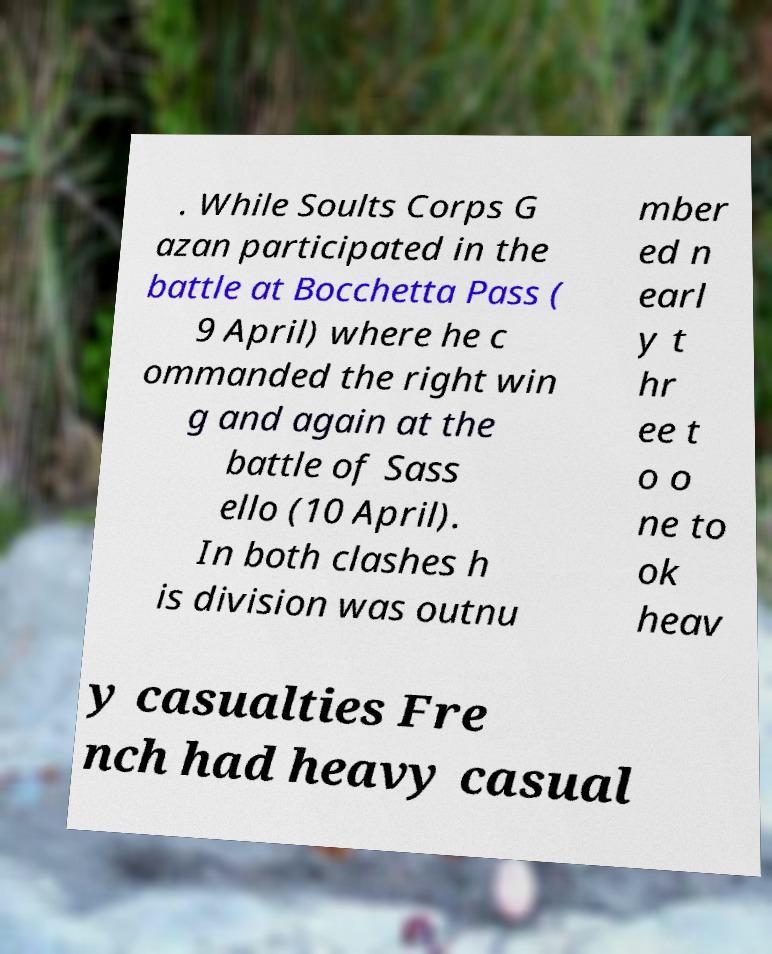I need the written content from this picture converted into text. Can you do that? . While Soults Corps G azan participated in the battle at Bocchetta Pass ( 9 April) where he c ommanded the right win g and again at the battle of Sass ello (10 April). In both clashes h is division was outnu mber ed n earl y t hr ee t o o ne to ok heav y casualties Fre nch had heavy casual 